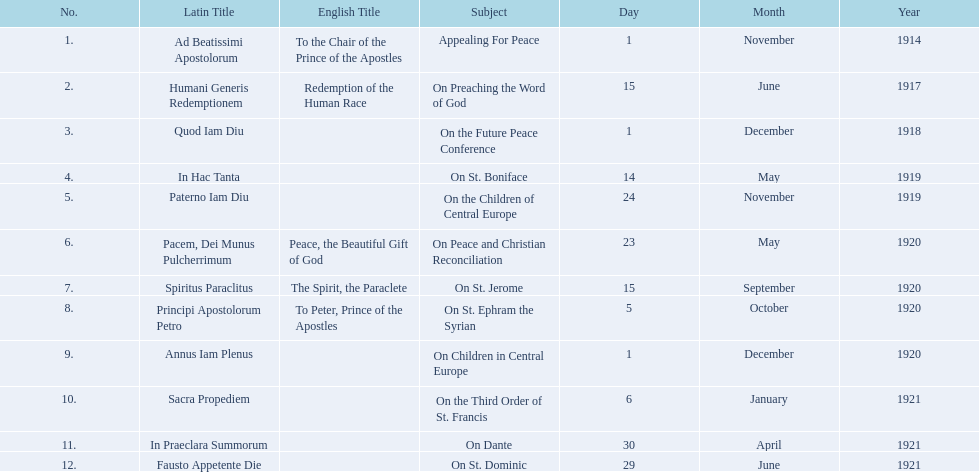What is the total number of encyclicals to take place in december? 2. 